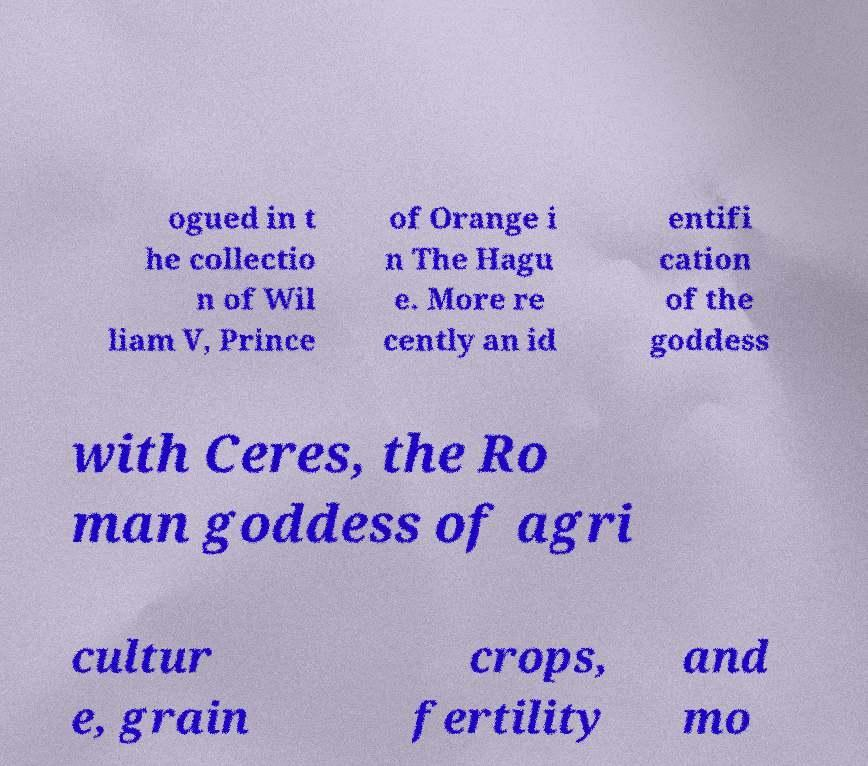There's text embedded in this image that I need extracted. Can you transcribe it verbatim? ogued in t he collectio n of Wil liam V, Prince of Orange i n The Hagu e. More re cently an id entifi cation of the goddess with Ceres, the Ro man goddess of agri cultur e, grain crops, fertility and mo 